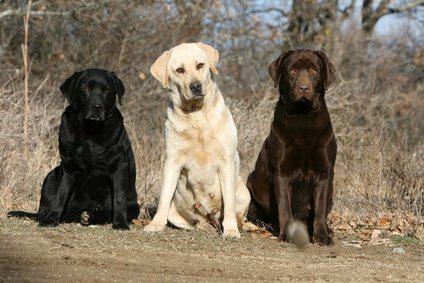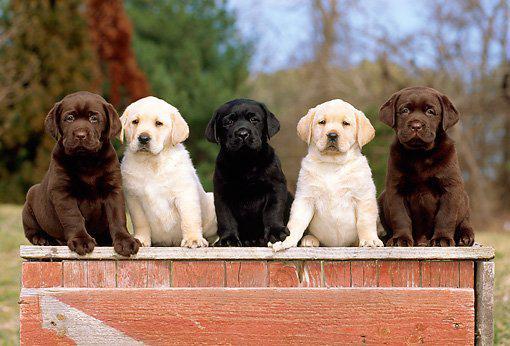The first image is the image on the left, the second image is the image on the right. Assess this claim about the two images: "Three dogs are sitting on the ground in the image on the left.". Correct or not? Answer yes or no. Yes. The first image is the image on the left, the second image is the image on the right. Assess this claim about the two images: "Each image shows at least three labrador retriever dogs sitting upright in a horizontal row.". Correct or not? Answer yes or no. Yes. 